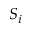Convert formula to latex. <formula><loc_0><loc_0><loc_500><loc_500>S _ { i }</formula> 